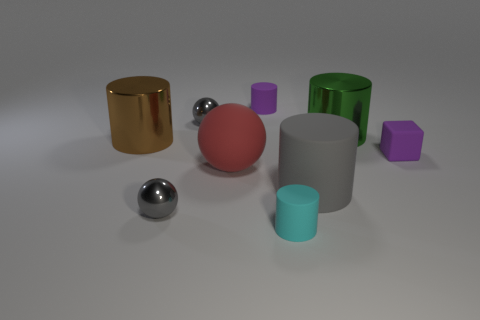Subtract 1 balls. How many balls are left? 2 Subtract all large brown metallic cylinders. How many cylinders are left? 4 Subtract all green cylinders. How many cylinders are left? 4 Subtract all blue cylinders. Subtract all red spheres. How many cylinders are left? 5 Add 1 tiny brown metal spheres. How many objects exist? 10 Subtract all cylinders. How many objects are left? 4 Subtract 1 purple cubes. How many objects are left? 8 Subtract all large blue objects. Subtract all gray things. How many objects are left? 6 Add 7 matte blocks. How many matte blocks are left? 8 Add 5 tiny gray blocks. How many tiny gray blocks exist? 5 